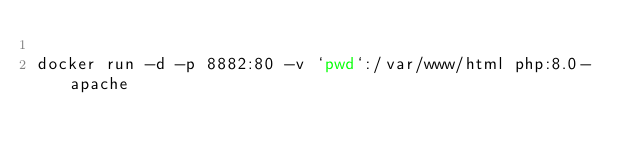Convert code to text. <code><loc_0><loc_0><loc_500><loc_500><_Bash_>
docker run -d -p 8882:80 -v `pwd`:/var/www/html php:8.0-apache</code> 